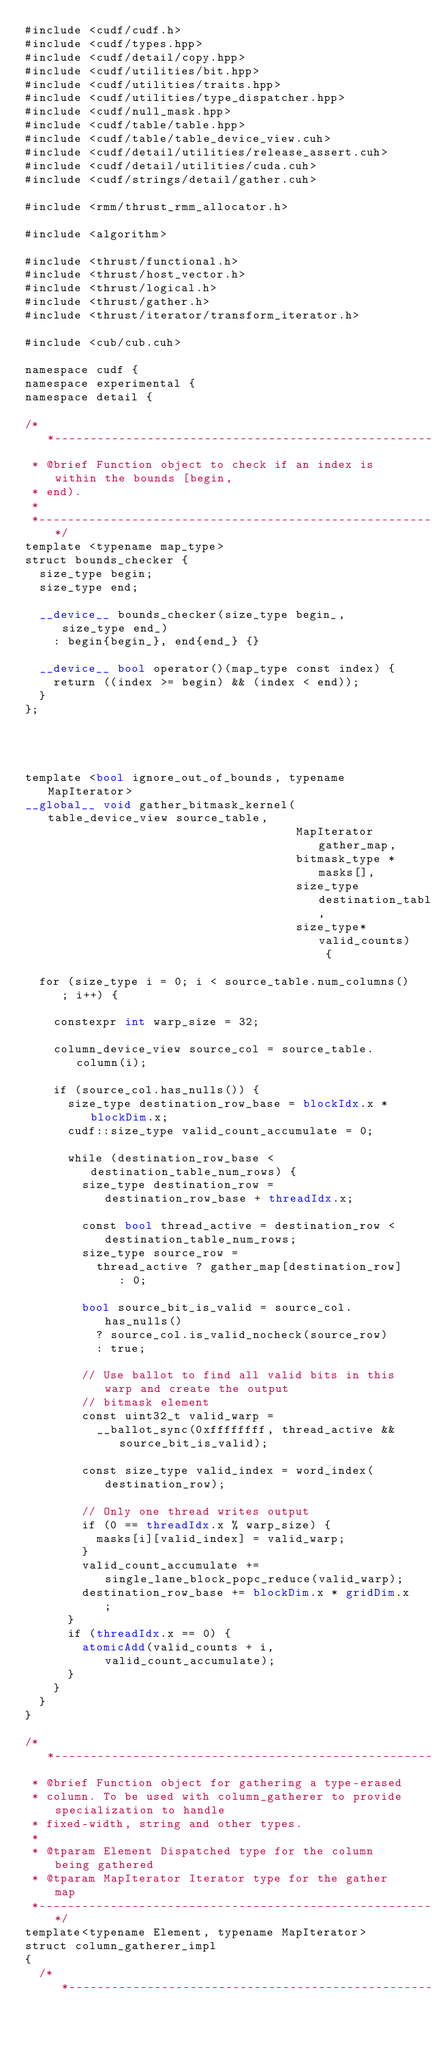<code> <loc_0><loc_0><loc_500><loc_500><_Cuda_>#include <cudf/cudf.h>
#include <cudf/types.hpp>
#include <cudf/detail/copy.hpp>
#include <cudf/utilities/bit.hpp>
#include <cudf/utilities/traits.hpp>
#include <cudf/utilities/type_dispatcher.hpp>
#include <cudf/null_mask.hpp>
#include <cudf/table/table.hpp>
#include <cudf/table/table_device_view.cuh>
#include <cudf/detail/utilities/release_assert.cuh>
#include <cudf/detail/utilities/cuda.cuh>
#include <cudf/strings/detail/gather.cuh>

#include <rmm/thrust_rmm_allocator.h>

#include <algorithm>

#include <thrust/functional.h>
#include <thrust/host_vector.h>
#include <thrust/logical.h>
#include <thrust/gather.h>
#include <thrust/iterator/transform_iterator.h>

#include <cub/cub.cuh>

namespace cudf {
namespace experimental {
namespace detail {

/**---------------------------------------------------------------------------*
 * @brief Function object to check if an index is within the bounds [begin,
 * end).
 *
 *---------------------------------------------------------------------------**/
template <typename map_type>
struct bounds_checker {
  size_type begin;
  size_type end;

  __device__ bounds_checker(size_type begin_, size_type end_)
    : begin{begin_}, end{end_} {}

  __device__ bool operator()(map_type const index) {
    return ((index >= begin) && (index < end));
  }
};




template <bool ignore_out_of_bounds, typename MapIterator>
__global__ void gather_bitmask_kernel(table_device_view source_table,
                                      MapIterator gather_map,
                                      bitmask_type * masks[],
                                      size_type destination_table_num_rows,
                                      size_type* valid_counts) {

  for (size_type i = 0; i < source_table.num_columns(); i++) {

    constexpr int warp_size = 32;

    column_device_view source_col = source_table.column(i);

    if (source_col.has_nulls()) {
      size_type destination_row_base = blockIdx.x * blockDim.x;
      cudf::size_type valid_count_accumulate = 0;

      while (destination_row_base < destination_table_num_rows) {
        size_type destination_row = destination_row_base + threadIdx.x;

        const bool thread_active = destination_row < destination_table_num_rows;
        size_type source_row =
          thread_active ? gather_map[destination_row] : 0;

        bool source_bit_is_valid = source_col.has_nulls()
          ? source_col.is_valid_nocheck(source_row)
          : true;

        // Use ballot to find all valid bits in this warp and create the output
        // bitmask element
        const uint32_t valid_warp =
          __ballot_sync(0xffffffff, thread_active && source_bit_is_valid);

        const size_type valid_index = word_index(destination_row);

        // Only one thread writes output
        if (0 == threadIdx.x % warp_size) {
          masks[i][valid_index] = valid_warp;
        }
        valid_count_accumulate += single_lane_block_popc_reduce(valid_warp);
        destination_row_base += blockDim.x * gridDim.x;
      }
      if (threadIdx.x == 0) {
        atomicAdd(valid_counts + i, valid_count_accumulate);
      }
    }
  }
}

/**---------------------------------------------------------------------------*
 * @brief Function object for gathering a type-erased
 * column. To be used with column_gatherer to provide specialization to handle
 * fixed-width, string and other types.
 *
 * @tparam Element Dispatched type for the column being gathered
 * @tparam MapIterator Iterator type for the gather map
 *---------------------------------------------------------------------------**/
template<typename Element, typename MapIterator>
struct column_gatherer_impl
{
  /**---------------------------------------------------------------------------*</code> 